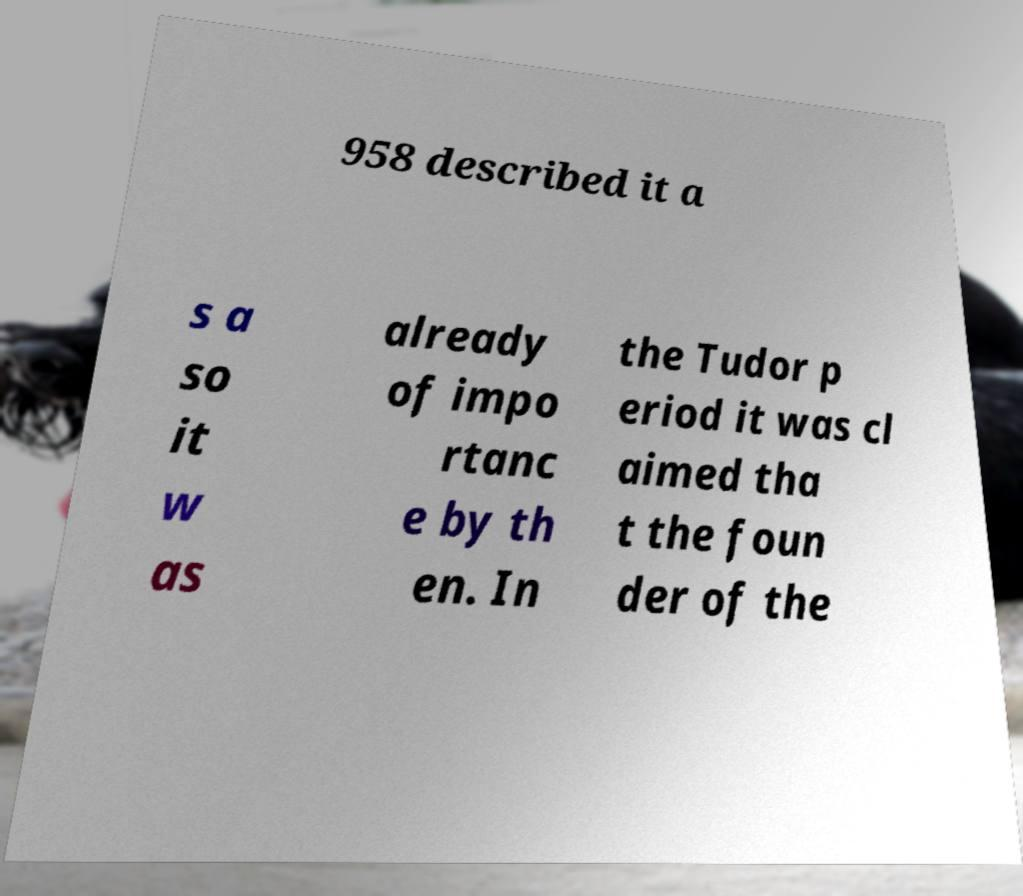What messages or text are displayed in this image? I need them in a readable, typed format. 958 described it a s a so it w as already of impo rtanc e by th en. In the Tudor p eriod it was cl aimed tha t the foun der of the 